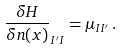Convert formula to latex. <formula><loc_0><loc_0><loc_500><loc_500>\frac { \delta H } { \delta n ( { x } ) } _ { I ^ { \prime } I } = \mu _ { I I ^ { \prime } } \, .</formula> 